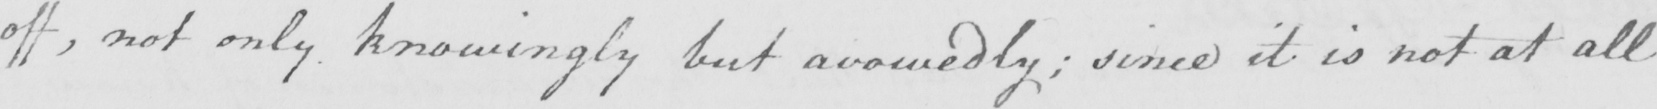Can you tell me what this handwritten text says? off , not only knowingly but avowedly ; since it is not at all 